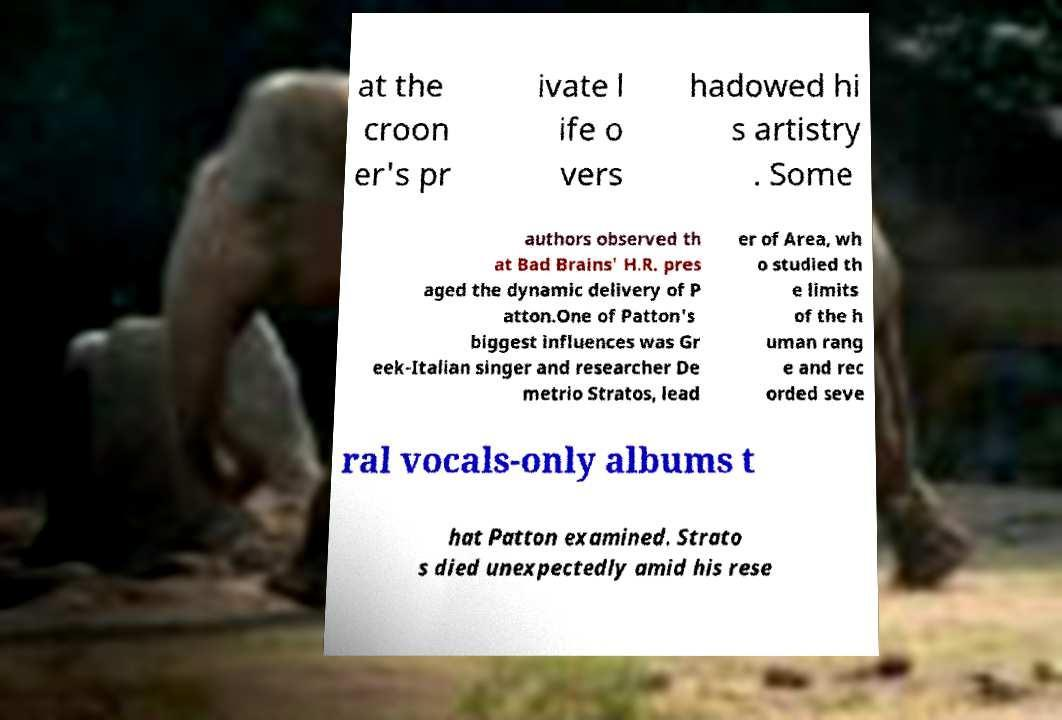For documentation purposes, I need the text within this image transcribed. Could you provide that? at the croon er's pr ivate l ife o vers hadowed hi s artistry . Some authors observed th at Bad Brains' H.R. pres aged the dynamic delivery of P atton.One of Patton's biggest influences was Gr eek-Italian singer and researcher De metrio Stratos, lead er of Area, wh o studied th e limits of the h uman rang e and rec orded seve ral vocals-only albums t hat Patton examined. Strato s died unexpectedly amid his rese 